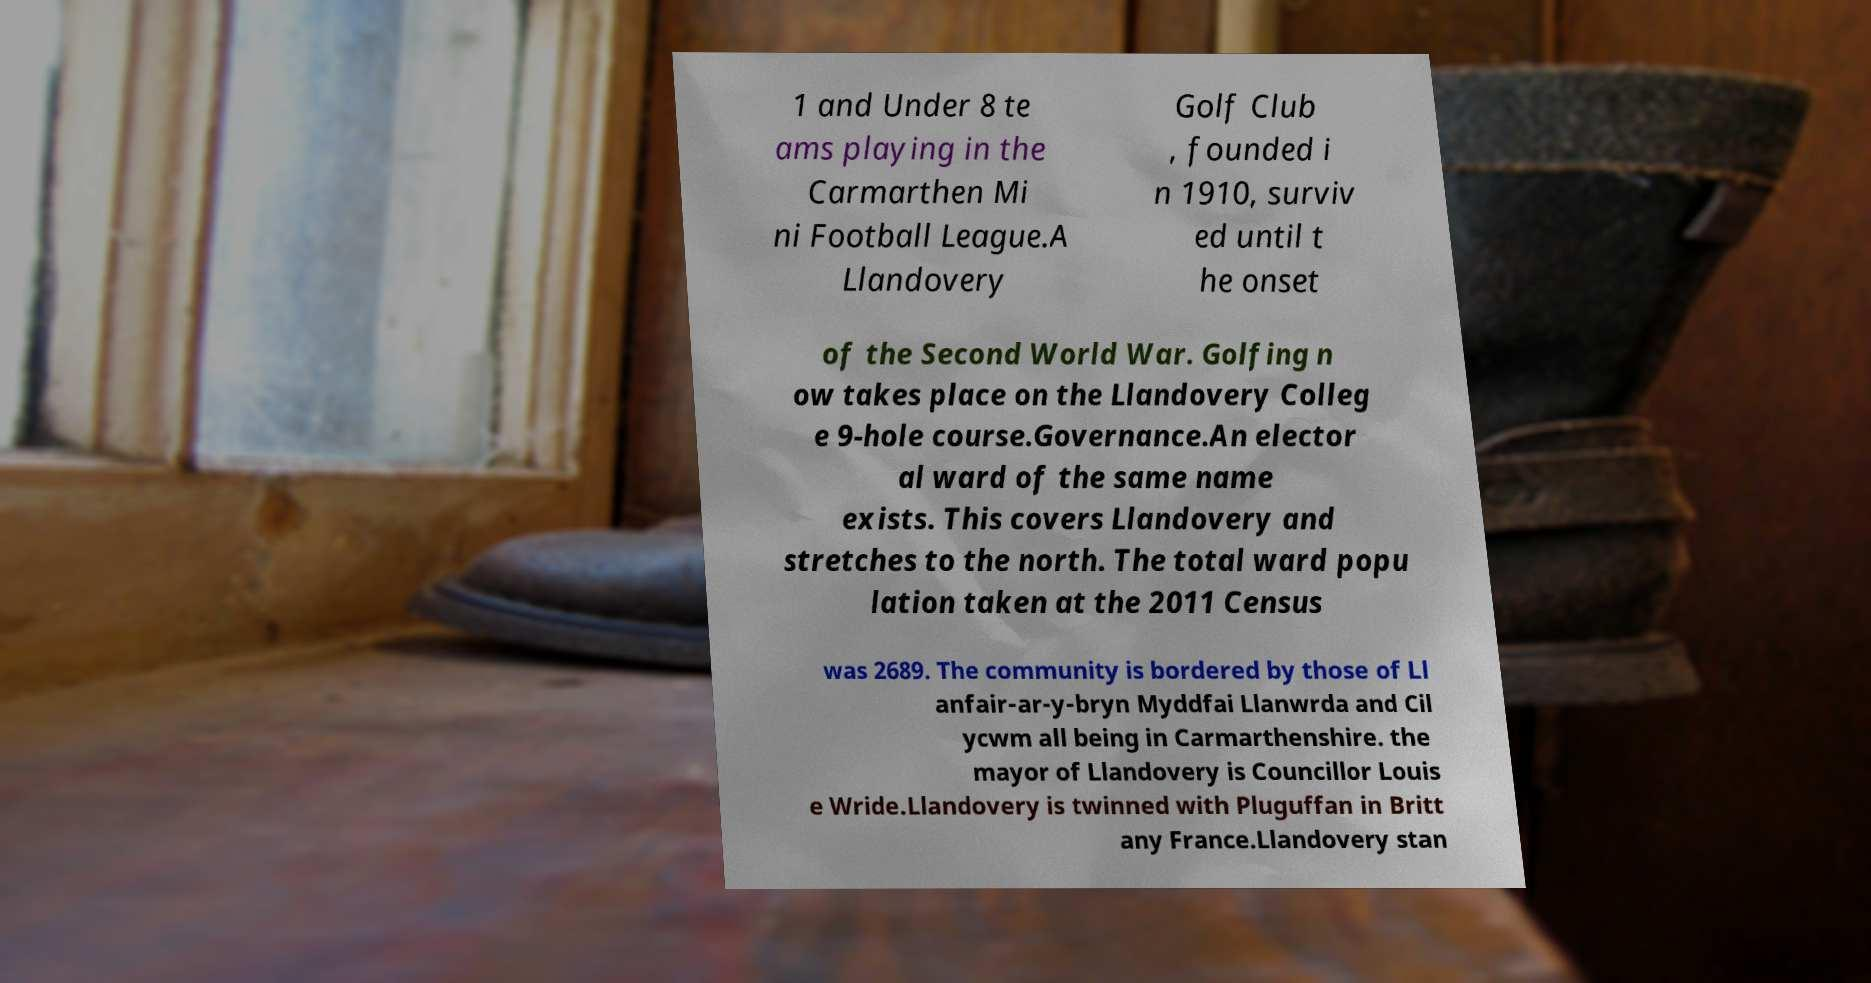Can you read and provide the text displayed in the image?This photo seems to have some interesting text. Can you extract and type it out for me? 1 and Under 8 te ams playing in the Carmarthen Mi ni Football League.A Llandovery Golf Club , founded i n 1910, surviv ed until t he onset of the Second World War. Golfing n ow takes place on the Llandovery Colleg e 9-hole course.Governance.An elector al ward of the same name exists. This covers Llandovery and stretches to the north. The total ward popu lation taken at the 2011 Census was 2689. The community is bordered by those of Ll anfair-ar-y-bryn Myddfai Llanwrda and Cil ycwm all being in Carmarthenshire. the mayor of Llandovery is Councillor Louis e Wride.Llandovery is twinned with Pluguffan in Britt any France.Llandovery stan 